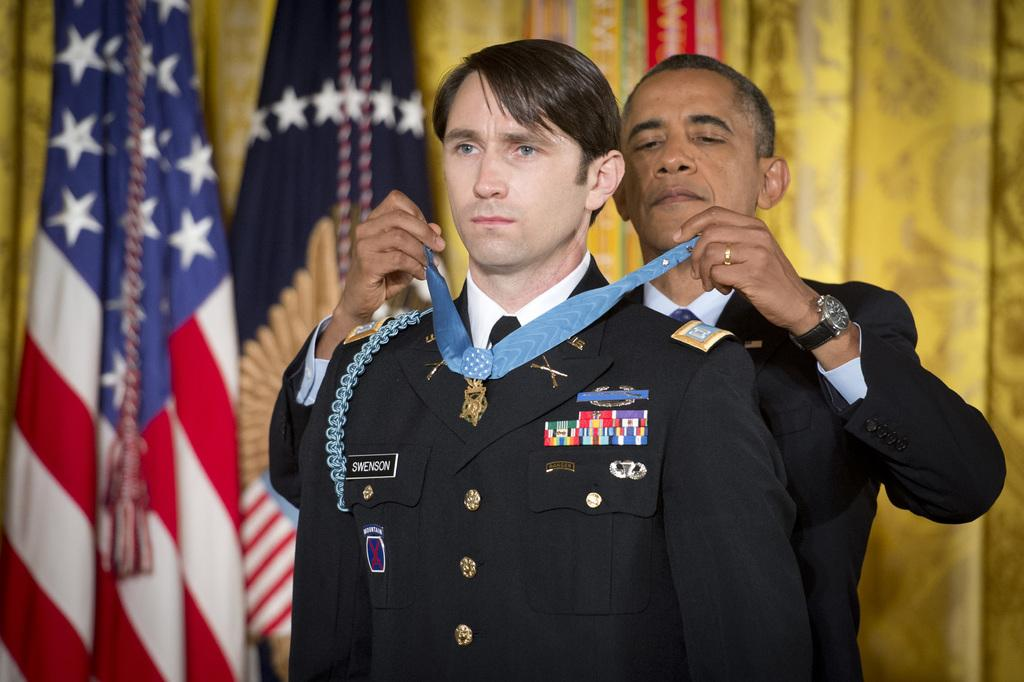<image>
Relay a brief, clear account of the picture shown. President Obama awarding the soldier Swenson a medal. 